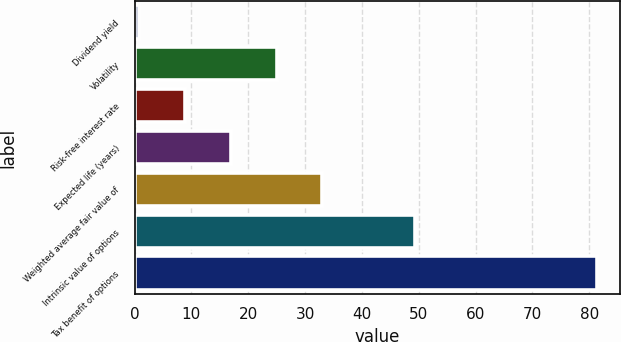Convert chart to OTSL. <chart><loc_0><loc_0><loc_500><loc_500><bar_chart><fcel>Dividend yield<fcel>Volatility<fcel>Risk-free interest rate<fcel>Expected life (years)<fcel>Weighted average fair value of<fcel>Intrinsic value of options<fcel>Tax benefit of options<nl><fcel>0.8<fcel>24.98<fcel>8.86<fcel>16.92<fcel>33.04<fcel>49.4<fcel>81.4<nl></chart> 